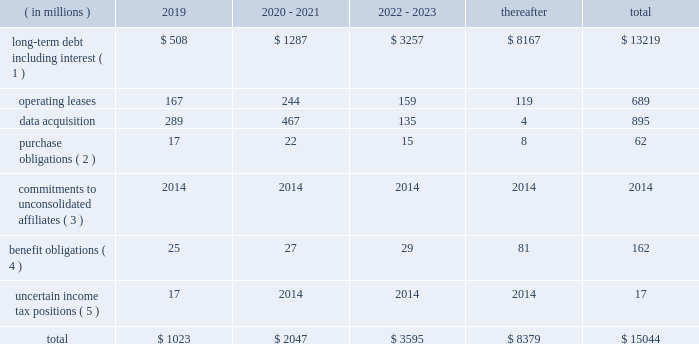Contingencies we are exposed to certain known contingencies that are material to our investors .
The facts and circumstances surrounding these contingencies and a discussion of their effect on us are in note 12 to our audited consolidated financial statements included elsewhere in this annual report on form 10-k .
These contingencies may have a material effect on our liquidity , capital resources or results of operations .
In addition , even where our reserves are adequate , the incurrence of any of these liabilities may have a material effect on our liquidity and the amount of cash available to us for other purposes .
We believe that we have made appropriate arrangements in respect of the future effect on us of these known contingencies .
We also believe that the amount of cash available to us from our operations , together with cash from financing , will be sufficient for us to pay any known contingencies as they become due without materially affecting our ability to conduct our operations and invest in the growth of our business .
Off-balance sheet arrangements we do not have any off-balance sheet arrangements except for operating leases entered into in the normal course of business .
Contractual obligations and commitments below is a summary of our future payment commitments by year under contractual obligations as of december 31 , 2018: .
( 1 ) interest payments on our debt are based on the interest rates in effect on december 31 , 2018 .
( 2 ) purchase obligations are defined as agreements to purchase goods or services that are enforceable and legally binding and that specify all significant terms , including fixed or minimum quantities to be purchased , fixed , minimum or variable pricing provisions and the approximate timing of the transactions .
( 3 ) we are currently committed to invest $ 120 million in private equity funds .
As of december 31 , 2018 , we have funded approximately $ 78 million of these commitments and we have approximately $ 42 million remaining to be funded which has not been included in the above table as we are unable to predict when these commitments will be paid .
( 4 ) amounts represent expected future benefit payments for our pension and postretirement benefit plans , as well as expected contributions for 2019 for our funded pension benefit plans .
We made cash contributions totaling approximately $ 31 million to our defined benefit plans in 2018 , and we estimate that we will make contributions totaling approximately $ 25 million to our defined benefit plans in 2019 .
Due to the potential impact of future plan investment performance , changes in interest rates , changes in other economic and demographic assumptions and changes in legislation in foreign jurisdictions , we are not able to reasonably estimate the timing and amount of contributions that may be required to fund our defined benefit plans for periods beyond 2019 .
( 5 ) as of december 31 , 2018 , our liability related to uncertain income tax positions was approximately $ 106 million , $ 89 million of which has not been included in the above table as we are unable to predict when these liabilities will be paid due to the uncertainties in the timing of the settlement of the income tax positions. .
Based on the summary of total future payment commitments of long-term debt including interest due that was the percent of the in 2019? 
Computations: (508 / 13219)
Answer: 0.03843. 